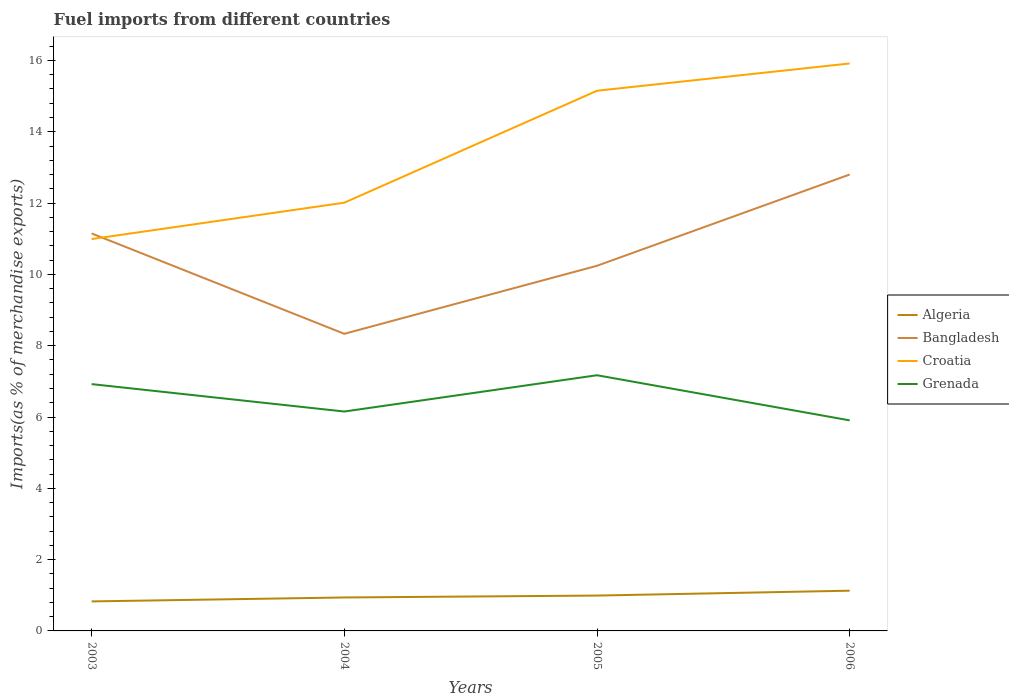Does the line corresponding to Bangladesh intersect with the line corresponding to Croatia?
Ensure brevity in your answer.  Yes. Is the number of lines equal to the number of legend labels?
Give a very brief answer. Yes. Across all years, what is the maximum percentage of imports to different countries in Grenada?
Your answer should be very brief. 5.91. In which year was the percentage of imports to different countries in Croatia maximum?
Ensure brevity in your answer.  2003. What is the total percentage of imports to different countries in Bangladesh in the graph?
Provide a succinct answer. -1.91. What is the difference between the highest and the second highest percentage of imports to different countries in Croatia?
Give a very brief answer. 4.93. What is the difference between the highest and the lowest percentage of imports to different countries in Algeria?
Offer a terse response. 2. How many years are there in the graph?
Offer a very short reply. 4. Are the values on the major ticks of Y-axis written in scientific E-notation?
Offer a very short reply. No. Where does the legend appear in the graph?
Keep it short and to the point. Center right. How many legend labels are there?
Give a very brief answer. 4. What is the title of the graph?
Ensure brevity in your answer.  Fuel imports from different countries. What is the label or title of the Y-axis?
Provide a short and direct response. Imports(as % of merchandise exports). What is the Imports(as % of merchandise exports) of Algeria in 2003?
Your response must be concise. 0.83. What is the Imports(as % of merchandise exports) in Bangladesh in 2003?
Ensure brevity in your answer.  11.15. What is the Imports(as % of merchandise exports) of Croatia in 2003?
Keep it short and to the point. 10.99. What is the Imports(as % of merchandise exports) in Grenada in 2003?
Make the answer very short. 6.92. What is the Imports(as % of merchandise exports) in Algeria in 2004?
Ensure brevity in your answer.  0.94. What is the Imports(as % of merchandise exports) in Bangladesh in 2004?
Offer a very short reply. 8.33. What is the Imports(as % of merchandise exports) of Croatia in 2004?
Keep it short and to the point. 12.01. What is the Imports(as % of merchandise exports) in Grenada in 2004?
Your response must be concise. 6.15. What is the Imports(as % of merchandise exports) of Algeria in 2005?
Your response must be concise. 0.99. What is the Imports(as % of merchandise exports) in Bangladesh in 2005?
Make the answer very short. 10.24. What is the Imports(as % of merchandise exports) in Croatia in 2005?
Keep it short and to the point. 15.15. What is the Imports(as % of merchandise exports) of Grenada in 2005?
Give a very brief answer. 7.17. What is the Imports(as % of merchandise exports) in Algeria in 2006?
Your response must be concise. 1.13. What is the Imports(as % of merchandise exports) in Bangladesh in 2006?
Your response must be concise. 12.8. What is the Imports(as % of merchandise exports) of Croatia in 2006?
Provide a short and direct response. 15.92. What is the Imports(as % of merchandise exports) of Grenada in 2006?
Offer a very short reply. 5.91. Across all years, what is the maximum Imports(as % of merchandise exports) in Algeria?
Your response must be concise. 1.13. Across all years, what is the maximum Imports(as % of merchandise exports) in Bangladesh?
Make the answer very short. 12.8. Across all years, what is the maximum Imports(as % of merchandise exports) of Croatia?
Provide a succinct answer. 15.92. Across all years, what is the maximum Imports(as % of merchandise exports) in Grenada?
Keep it short and to the point. 7.17. Across all years, what is the minimum Imports(as % of merchandise exports) in Algeria?
Provide a succinct answer. 0.83. Across all years, what is the minimum Imports(as % of merchandise exports) of Bangladesh?
Offer a terse response. 8.33. Across all years, what is the minimum Imports(as % of merchandise exports) of Croatia?
Make the answer very short. 10.99. Across all years, what is the minimum Imports(as % of merchandise exports) of Grenada?
Offer a very short reply. 5.91. What is the total Imports(as % of merchandise exports) of Algeria in the graph?
Your answer should be very brief. 3.89. What is the total Imports(as % of merchandise exports) in Bangladesh in the graph?
Provide a short and direct response. 42.53. What is the total Imports(as % of merchandise exports) in Croatia in the graph?
Ensure brevity in your answer.  54.07. What is the total Imports(as % of merchandise exports) of Grenada in the graph?
Give a very brief answer. 26.15. What is the difference between the Imports(as % of merchandise exports) of Algeria in 2003 and that in 2004?
Ensure brevity in your answer.  -0.11. What is the difference between the Imports(as % of merchandise exports) in Bangladesh in 2003 and that in 2004?
Provide a short and direct response. 2.82. What is the difference between the Imports(as % of merchandise exports) in Croatia in 2003 and that in 2004?
Keep it short and to the point. -1.02. What is the difference between the Imports(as % of merchandise exports) in Grenada in 2003 and that in 2004?
Keep it short and to the point. 0.77. What is the difference between the Imports(as % of merchandise exports) in Algeria in 2003 and that in 2005?
Offer a terse response. -0.16. What is the difference between the Imports(as % of merchandise exports) of Bangladesh in 2003 and that in 2005?
Offer a terse response. 0.91. What is the difference between the Imports(as % of merchandise exports) in Croatia in 2003 and that in 2005?
Your answer should be compact. -4.16. What is the difference between the Imports(as % of merchandise exports) in Grenada in 2003 and that in 2005?
Keep it short and to the point. -0.25. What is the difference between the Imports(as % of merchandise exports) of Algeria in 2003 and that in 2006?
Ensure brevity in your answer.  -0.3. What is the difference between the Imports(as % of merchandise exports) in Bangladesh in 2003 and that in 2006?
Offer a terse response. -1.65. What is the difference between the Imports(as % of merchandise exports) of Croatia in 2003 and that in 2006?
Your answer should be compact. -4.93. What is the difference between the Imports(as % of merchandise exports) of Grenada in 2003 and that in 2006?
Ensure brevity in your answer.  1.02. What is the difference between the Imports(as % of merchandise exports) of Algeria in 2004 and that in 2005?
Your answer should be compact. -0.05. What is the difference between the Imports(as % of merchandise exports) in Bangladesh in 2004 and that in 2005?
Your response must be concise. -1.91. What is the difference between the Imports(as % of merchandise exports) in Croatia in 2004 and that in 2005?
Your answer should be very brief. -3.14. What is the difference between the Imports(as % of merchandise exports) in Grenada in 2004 and that in 2005?
Make the answer very short. -1.02. What is the difference between the Imports(as % of merchandise exports) of Algeria in 2004 and that in 2006?
Provide a short and direct response. -0.19. What is the difference between the Imports(as % of merchandise exports) in Bangladesh in 2004 and that in 2006?
Keep it short and to the point. -4.47. What is the difference between the Imports(as % of merchandise exports) of Croatia in 2004 and that in 2006?
Offer a terse response. -3.9. What is the difference between the Imports(as % of merchandise exports) in Grenada in 2004 and that in 2006?
Your response must be concise. 0.25. What is the difference between the Imports(as % of merchandise exports) of Algeria in 2005 and that in 2006?
Provide a succinct answer. -0.14. What is the difference between the Imports(as % of merchandise exports) in Bangladesh in 2005 and that in 2006?
Give a very brief answer. -2.56. What is the difference between the Imports(as % of merchandise exports) of Croatia in 2005 and that in 2006?
Keep it short and to the point. -0.76. What is the difference between the Imports(as % of merchandise exports) of Grenada in 2005 and that in 2006?
Your response must be concise. 1.27. What is the difference between the Imports(as % of merchandise exports) of Algeria in 2003 and the Imports(as % of merchandise exports) of Bangladesh in 2004?
Provide a succinct answer. -7.51. What is the difference between the Imports(as % of merchandise exports) of Algeria in 2003 and the Imports(as % of merchandise exports) of Croatia in 2004?
Ensure brevity in your answer.  -11.18. What is the difference between the Imports(as % of merchandise exports) in Algeria in 2003 and the Imports(as % of merchandise exports) in Grenada in 2004?
Ensure brevity in your answer.  -5.33. What is the difference between the Imports(as % of merchandise exports) of Bangladesh in 2003 and the Imports(as % of merchandise exports) of Croatia in 2004?
Your response must be concise. -0.86. What is the difference between the Imports(as % of merchandise exports) in Bangladesh in 2003 and the Imports(as % of merchandise exports) in Grenada in 2004?
Provide a succinct answer. 5. What is the difference between the Imports(as % of merchandise exports) of Croatia in 2003 and the Imports(as % of merchandise exports) of Grenada in 2004?
Keep it short and to the point. 4.84. What is the difference between the Imports(as % of merchandise exports) of Algeria in 2003 and the Imports(as % of merchandise exports) of Bangladesh in 2005?
Ensure brevity in your answer.  -9.41. What is the difference between the Imports(as % of merchandise exports) of Algeria in 2003 and the Imports(as % of merchandise exports) of Croatia in 2005?
Ensure brevity in your answer.  -14.32. What is the difference between the Imports(as % of merchandise exports) of Algeria in 2003 and the Imports(as % of merchandise exports) of Grenada in 2005?
Keep it short and to the point. -6.34. What is the difference between the Imports(as % of merchandise exports) in Bangladesh in 2003 and the Imports(as % of merchandise exports) in Croatia in 2005?
Your answer should be very brief. -4. What is the difference between the Imports(as % of merchandise exports) of Bangladesh in 2003 and the Imports(as % of merchandise exports) of Grenada in 2005?
Make the answer very short. 3.98. What is the difference between the Imports(as % of merchandise exports) of Croatia in 2003 and the Imports(as % of merchandise exports) of Grenada in 2005?
Make the answer very short. 3.82. What is the difference between the Imports(as % of merchandise exports) in Algeria in 2003 and the Imports(as % of merchandise exports) in Bangladesh in 2006?
Offer a terse response. -11.97. What is the difference between the Imports(as % of merchandise exports) of Algeria in 2003 and the Imports(as % of merchandise exports) of Croatia in 2006?
Your answer should be compact. -15.09. What is the difference between the Imports(as % of merchandise exports) of Algeria in 2003 and the Imports(as % of merchandise exports) of Grenada in 2006?
Offer a very short reply. -5.08. What is the difference between the Imports(as % of merchandise exports) of Bangladesh in 2003 and the Imports(as % of merchandise exports) of Croatia in 2006?
Give a very brief answer. -4.77. What is the difference between the Imports(as % of merchandise exports) in Bangladesh in 2003 and the Imports(as % of merchandise exports) in Grenada in 2006?
Offer a very short reply. 5.24. What is the difference between the Imports(as % of merchandise exports) of Croatia in 2003 and the Imports(as % of merchandise exports) of Grenada in 2006?
Your answer should be compact. 5.09. What is the difference between the Imports(as % of merchandise exports) of Algeria in 2004 and the Imports(as % of merchandise exports) of Bangladesh in 2005?
Offer a terse response. -9.3. What is the difference between the Imports(as % of merchandise exports) in Algeria in 2004 and the Imports(as % of merchandise exports) in Croatia in 2005?
Provide a succinct answer. -14.21. What is the difference between the Imports(as % of merchandise exports) of Algeria in 2004 and the Imports(as % of merchandise exports) of Grenada in 2005?
Your answer should be very brief. -6.23. What is the difference between the Imports(as % of merchandise exports) in Bangladesh in 2004 and the Imports(as % of merchandise exports) in Croatia in 2005?
Ensure brevity in your answer.  -6.82. What is the difference between the Imports(as % of merchandise exports) of Bangladesh in 2004 and the Imports(as % of merchandise exports) of Grenada in 2005?
Give a very brief answer. 1.16. What is the difference between the Imports(as % of merchandise exports) in Croatia in 2004 and the Imports(as % of merchandise exports) in Grenada in 2005?
Offer a terse response. 4.84. What is the difference between the Imports(as % of merchandise exports) of Algeria in 2004 and the Imports(as % of merchandise exports) of Bangladesh in 2006?
Provide a short and direct response. -11.86. What is the difference between the Imports(as % of merchandise exports) in Algeria in 2004 and the Imports(as % of merchandise exports) in Croatia in 2006?
Make the answer very short. -14.98. What is the difference between the Imports(as % of merchandise exports) of Algeria in 2004 and the Imports(as % of merchandise exports) of Grenada in 2006?
Keep it short and to the point. -4.97. What is the difference between the Imports(as % of merchandise exports) of Bangladesh in 2004 and the Imports(as % of merchandise exports) of Croatia in 2006?
Offer a very short reply. -7.58. What is the difference between the Imports(as % of merchandise exports) of Bangladesh in 2004 and the Imports(as % of merchandise exports) of Grenada in 2006?
Your response must be concise. 2.43. What is the difference between the Imports(as % of merchandise exports) of Croatia in 2004 and the Imports(as % of merchandise exports) of Grenada in 2006?
Your answer should be very brief. 6.11. What is the difference between the Imports(as % of merchandise exports) of Algeria in 2005 and the Imports(as % of merchandise exports) of Bangladesh in 2006?
Your response must be concise. -11.81. What is the difference between the Imports(as % of merchandise exports) in Algeria in 2005 and the Imports(as % of merchandise exports) in Croatia in 2006?
Keep it short and to the point. -14.92. What is the difference between the Imports(as % of merchandise exports) in Algeria in 2005 and the Imports(as % of merchandise exports) in Grenada in 2006?
Your answer should be very brief. -4.91. What is the difference between the Imports(as % of merchandise exports) of Bangladesh in 2005 and the Imports(as % of merchandise exports) of Croatia in 2006?
Provide a short and direct response. -5.67. What is the difference between the Imports(as % of merchandise exports) in Bangladesh in 2005 and the Imports(as % of merchandise exports) in Grenada in 2006?
Your answer should be very brief. 4.34. What is the difference between the Imports(as % of merchandise exports) in Croatia in 2005 and the Imports(as % of merchandise exports) in Grenada in 2006?
Offer a very short reply. 9.25. What is the average Imports(as % of merchandise exports) in Algeria per year?
Give a very brief answer. 0.97. What is the average Imports(as % of merchandise exports) in Bangladesh per year?
Make the answer very short. 10.63. What is the average Imports(as % of merchandise exports) of Croatia per year?
Keep it short and to the point. 13.52. What is the average Imports(as % of merchandise exports) of Grenada per year?
Ensure brevity in your answer.  6.54. In the year 2003, what is the difference between the Imports(as % of merchandise exports) of Algeria and Imports(as % of merchandise exports) of Bangladesh?
Your answer should be compact. -10.32. In the year 2003, what is the difference between the Imports(as % of merchandise exports) of Algeria and Imports(as % of merchandise exports) of Croatia?
Your answer should be very brief. -10.16. In the year 2003, what is the difference between the Imports(as % of merchandise exports) in Algeria and Imports(as % of merchandise exports) in Grenada?
Give a very brief answer. -6.1. In the year 2003, what is the difference between the Imports(as % of merchandise exports) of Bangladesh and Imports(as % of merchandise exports) of Croatia?
Make the answer very short. 0.16. In the year 2003, what is the difference between the Imports(as % of merchandise exports) in Bangladesh and Imports(as % of merchandise exports) in Grenada?
Keep it short and to the point. 4.23. In the year 2003, what is the difference between the Imports(as % of merchandise exports) in Croatia and Imports(as % of merchandise exports) in Grenada?
Your answer should be very brief. 4.07. In the year 2004, what is the difference between the Imports(as % of merchandise exports) in Algeria and Imports(as % of merchandise exports) in Bangladesh?
Provide a succinct answer. -7.4. In the year 2004, what is the difference between the Imports(as % of merchandise exports) of Algeria and Imports(as % of merchandise exports) of Croatia?
Give a very brief answer. -11.07. In the year 2004, what is the difference between the Imports(as % of merchandise exports) in Algeria and Imports(as % of merchandise exports) in Grenada?
Your answer should be compact. -5.22. In the year 2004, what is the difference between the Imports(as % of merchandise exports) of Bangladesh and Imports(as % of merchandise exports) of Croatia?
Your answer should be compact. -3.68. In the year 2004, what is the difference between the Imports(as % of merchandise exports) in Bangladesh and Imports(as % of merchandise exports) in Grenada?
Offer a very short reply. 2.18. In the year 2004, what is the difference between the Imports(as % of merchandise exports) in Croatia and Imports(as % of merchandise exports) in Grenada?
Provide a succinct answer. 5.86. In the year 2005, what is the difference between the Imports(as % of merchandise exports) in Algeria and Imports(as % of merchandise exports) in Bangladesh?
Provide a succinct answer. -9.25. In the year 2005, what is the difference between the Imports(as % of merchandise exports) of Algeria and Imports(as % of merchandise exports) of Croatia?
Provide a succinct answer. -14.16. In the year 2005, what is the difference between the Imports(as % of merchandise exports) of Algeria and Imports(as % of merchandise exports) of Grenada?
Your answer should be compact. -6.18. In the year 2005, what is the difference between the Imports(as % of merchandise exports) in Bangladesh and Imports(as % of merchandise exports) in Croatia?
Keep it short and to the point. -4.91. In the year 2005, what is the difference between the Imports(as % of merchandise exports) of Bangladesh and Imports(as % of merchandise exports) of Grenada?
Ensure brevity in your answer.  3.07. In the year 2005, what is the difference between the Imports(as % of merchandise exports) in Croatia and Imports(as % of merchandise exports) in Grenada?
Your answer should be very brief. 7.98. In the year 2006, what is the difference between the Imports(as % of merchandise exports) in Algeria and Imports(as % of merchandise exports) in Bangladesh?
Provide a short and direct response. -11.67. In the year 2006, what is the difference between the Imports(as % of merchandise exports) in Algeria and Imports(as % of merchandise exports) in Croatia?
Ensure brevity in your answer.  -14.79. In the year 2006, what is the difference between the Imports(as % of merchandise exports) of Algeria and Imports(as % of merchandise exports) of Grenada?
Provide a succinct answer. -4.78. In the year 2006, what is the difference between the Imports(as % of merchandise exports) of Bangladesh and Imports(as % of merchandise exports) of Croatia?
Keep it short and to the point. -3.11. In the year 2006, what is the difference between the Imports(as % of merchandise exports) in Bangladesh and Imports(as % of merchandise exports) in Grenada?
Provide a short and direct response. 6.9. In the year 2006, what is the difference between the Imports(as % of merchandise exports) in Croatia and Imports(as % of merchandise exports) in Grenada?
Give a very brief answer. 10.01. What is the ratio of the Imports(as % of merchandise exports) in Algeria in 2003 to that in 2004?
Offer a terse response. 0.88. What is the ratio of the Imports(as % of merchandise exports) in Bangladesh in 2003 to that in 2004?
Provide a succinct answer. 1.34. What is the ratio of the Imports(as % of merchandise exports) in Croatia in 2003 to that in 2004?
Offer a terse response. 0.92. What is the ratio of the Imports(as % of merchandise exports) of Algeria in 2003 to that in 2005?
Offer a terse response. 0.83. What is the ratio of the Imports(as % of merchandise exports) in Bangladesh in 2003 to that in 2005?
Your answer should be compact. 1.09. What is the ratio of the Imports(as % of merchandise exports) of Croatia in 2003 to that in 2005?
Make the answer very short. 0.73. What is the ratio of the Imports(as % of merchandise exports) in Grenada in 2003 to that in 2005?
Provide a short and direct response. 0.97. What is the ratio of the Imports(as % of merchandise exports) of Algeria in 2003 to that in 2006?
Offer a terse response. 0.73. What is the ratio of the Imports(as % of merchandise exports) of Bangladesh in 2003 to that in 2006?
Keep it short and to the point. 0.87. What is the ratio of the Imports(as % of merchandise exports) of Croatia in 2003 to that in 2006?
Keep it short and to the point. 0.69. What is the ratio of the Imports(as % of merchandise exports) in Grenada in 2003 to that in 2006?
Your answer should be compact. 1.17. What is the ratio of the Imports(as % of merchandise exports) in Algeria in 2004 to that in 2005?
Keep it short and to the point. 0.95. What is the ratio of the Imports(as % of merchandise exports) in Bangladesh in 2004 to that in 2005?
Provide a succinct answer. 0.81. What is the ratio of the Imports(as % of merchandise exports) of Croatia in 2004 to that in 2005?
Your answer should be compact. 0.79. What is the ratio of the Imports(as % of merchandise exports) in Grenada in 2004 to that in 2005?
Your answer should be compact. 0.86. What is the ratio of the Imports(as % of merchandise exports) of Algeria in 2004 to that in 2006?
Make the answer very short. 0.83. What is the ratio of the Imports(as % of merchandise exports) in Bangladesh in 2004 to that in 2006?
Your answer should be compact. 0.65. What is the ratio of the Imports(as % of merchandise exports) in Croatia in 2004 to that in 2006?
Provide a short and direct response. 0.75. What is the ratio of the Imports(as % of merchandise exports) in Grenada in 2004 to that in 2006?
Ensure brevity in your answer.  1.04. What is the ratio of the Imports(as % of merchandise exports) of Algeria in 2005 to that in 2006?
Make the answer very short. 0.88. What is the ratio of the Imports(as % of merchandise exports) in Bangladesh in 2005 to that in 2006?
Offer a terse response. 0.8. What is the ratio of the Imports(as % of merchandise exports) in Croatia in 2005 to that in 2006?
Give a very brief answer. 0.95. What is the ratio of the Imports(as % of merchandise exports) of Grenada in 2005 to that in 2006?
Keep it short and to the point. 1.21. What is the difference between the highest and the second highest Imports(as % of merchandise exports) in Algeria?
Ensure brevity in your answer.  0.14. What is the difference between the highest and the second highest Imports(as % of merchandise exports) of Bangladesh?
Your response must be concise. 1.65. What is the difference between the highest and the second highest Imports(as % of merchandise exports) in Croatia?
Offer a very short reply. 0.76. What is the difference between the highest and the second highest Imports(as % of merchandise exports) of Grenada?
Give a very brief answer. 0.25. What is the difference between the highest and the lowest Imports(as % of merchandise exports) in Algeria?
Provide a short and direct response. 0.3. What is the difference between the highest and the lowest Imports(as % of merchandise exports) of Bangladesh?
Your answer should be very brief. 4.47. What is the difference between the highest and the lowest Imports(as % of merchandise exports) in Croatia?
Your response must be concise. 4.93. What is the difference between the highest and the lowest Imports(as % of merchandise exports) in Grenada?
Your answer should be compact. 1.27. 